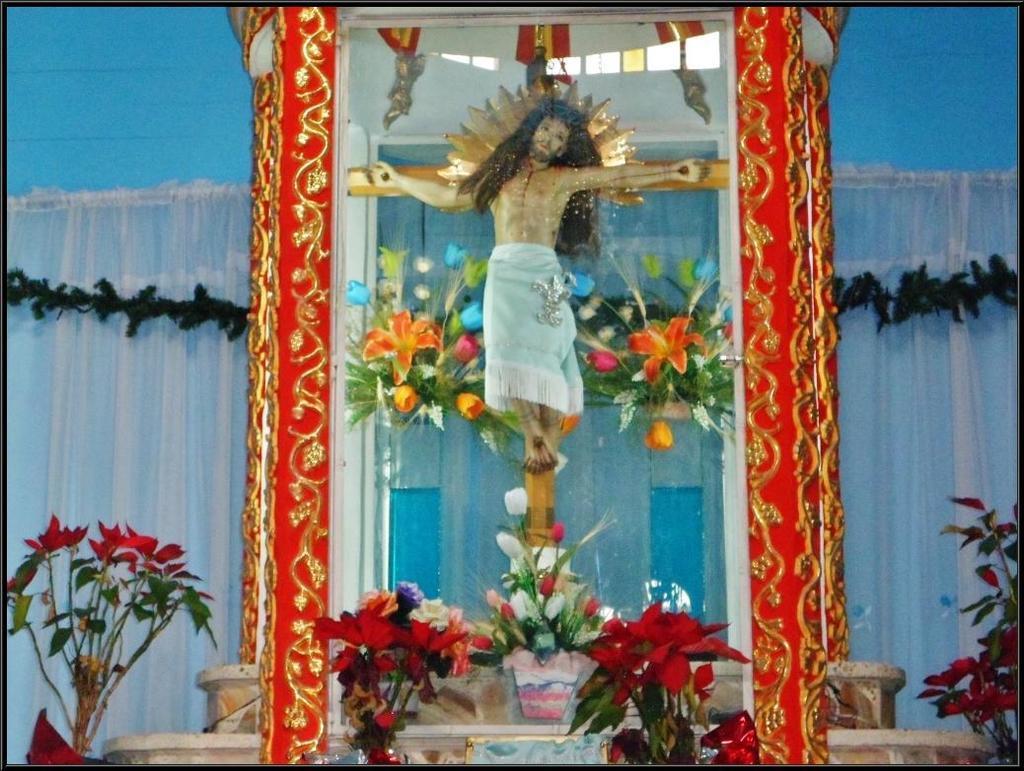Could you give a brief overview of what you see in this image? In this image I can see there is an idol placed in glass box, there are few artificial flowers arranged around it. 